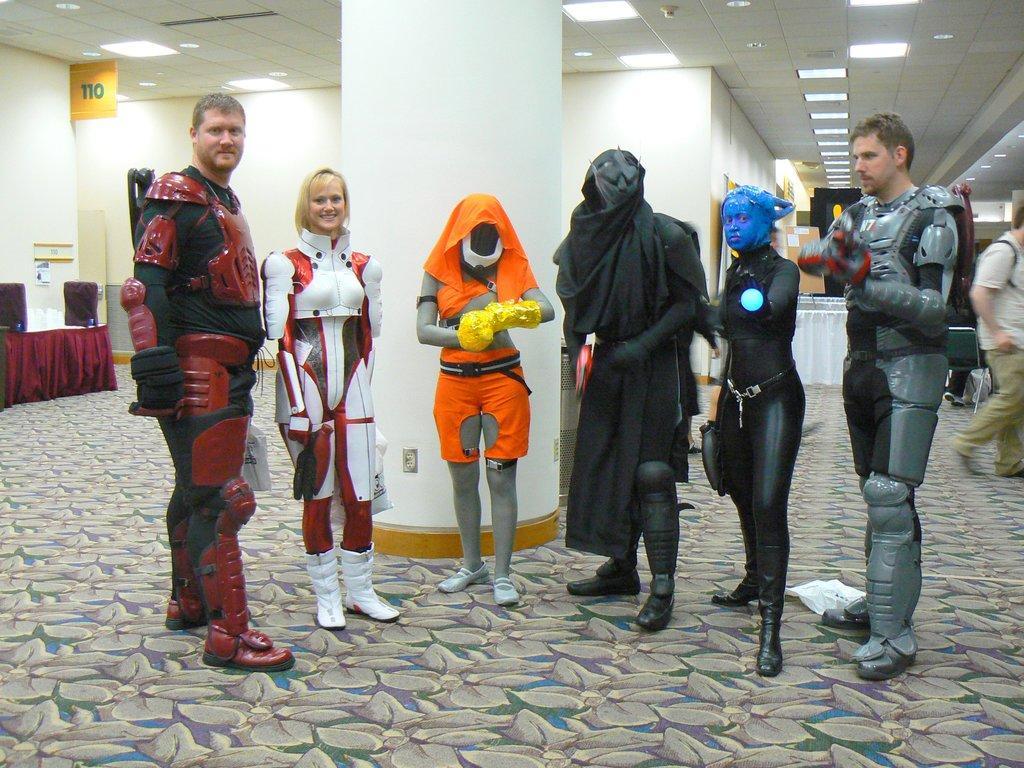Could you give a brief overview of what you see in this image? In the foreground of this image, there are persons standing on the floor. In the background, there is a pillar, lights to the ceiling, wall, few objects on the table, a man walking on the floor and few objects in the background. 